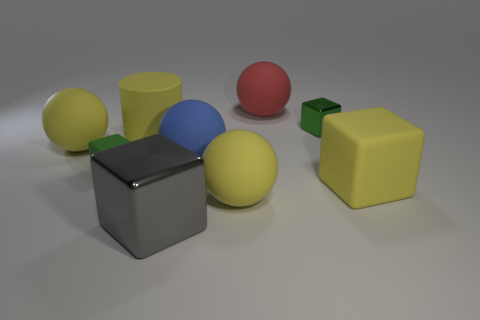Add 1 gray cubes. How many objects exist? 10 Subtract all green matte cubes. How many cubes are left? 3 Subtract 1 spheres. How many spheres are left? 3 Subtract all green cubes. How many cubes are left? 2 Subtract all cubes. How many objects are left? 5 Add 4 large cylinders. How many large cylinders exist? 5 Subtract 1 red spheres. How many objects are left? 8 Subtract all yellow balls. Subtract all yellow cubes. How many balls are left? 2 Subtract all cyan balls. How many cyan cylinders are left? 0 Subtract all matte spheres. Subtract all blocks. How many objects are left? 1 